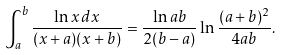Convert formula to latex. <formula><loc_0><loc_0><loc_500><loc_500>\int _ { a } ^ { b } \frac { \ln x \, d x } { ( x + a ) ( x + b ) } = \frac { \ln a b } { 2 ( b - a ) } \ln \frac { ( a + b ) ^ { 2 } } { 4 a b } .</formula> 